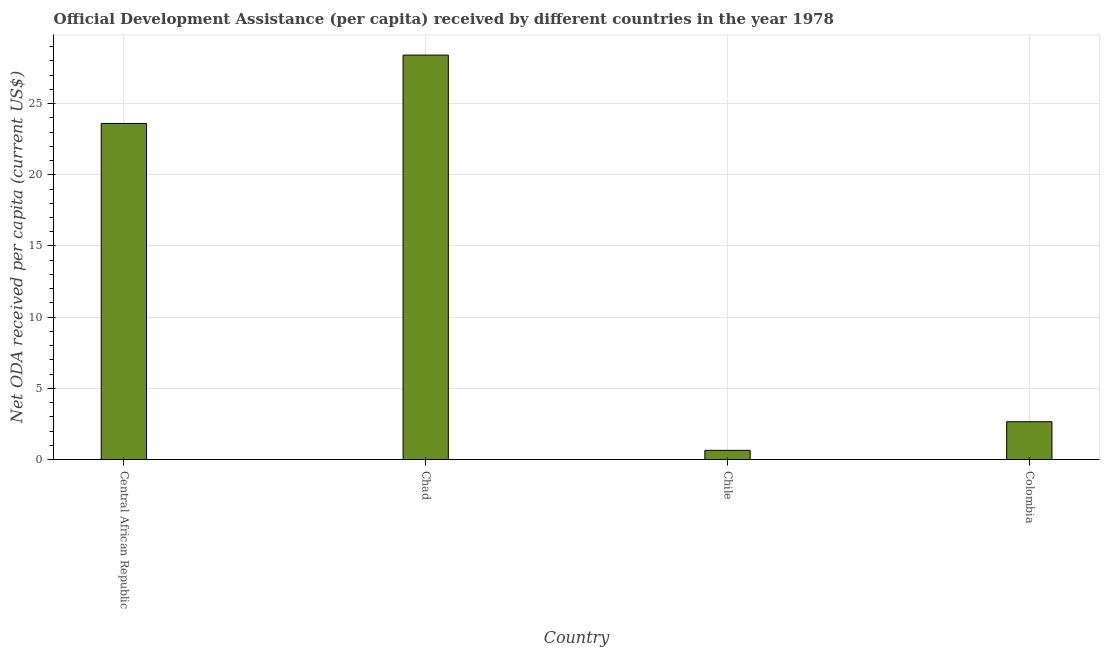What is the title of the graph?
Your response must be concise. Official Development Assistance (per capita) received by different countries in the year 1978. What is the label or title of the X-axis?
Ensure brevity in your answer.  Country. What is the label or title of the Y-axis?
Provide a short and direct response. Net ODA received per capita (current US$). What is the net oda received per capita in Chad?
Your answer should be compact. 28.4. Across all countries, what is the maximum net oda received per capita?
Provide a succinct answer. 28.4. Across all countries, what is the minimum net oda received per capita?
Ensure brevity in your answer.  0.66. In which country was the net oda received per capita maximum?
Offer a very short reply. Chad. What is the sum of the net oda received per capita?
Offer a very short reply. 55.32. What is the difference between the net oda received per capita in Chad and Colombia?
Your response must be concise. 25.73. What is the average net oda received per capita per country?
Offer a terse response. 13.83. What is the median net oda received per capita?
Provide a short and direct response. 13.13. What is the ratio of the net oda received per capita in Central African Republic to that in Chad?
Your response must be concise. 0.83. Is the difference between the net oda received per capita in Chad and Chile greater than the difference between any two countries?
Give a very brief answer. Yes. What is the difference between the highest and the second highest net oda received per capita?
Your answer should be compact. 4.8. Is the sum of the net oda received per capita in Chad and Colombia greater than the maximum net oda received per capita across all countries?
Offer a very short reply. Yes. What is the difference between the highest and the lowest net oda received per capita?
Provide a short and direct response. 27.74. In how many countries, is the net oda received per capita greater than the average net oda received per capita taken over all countries?
Provide a short and direct response. 2. What is the difference between two consecutive major ticks on the Y-axis?
Ensure brevity in your answer.  5. Are the values on the major ticks of Y-axis written in scientific E-notation?
Your answer should be compact. No. What is the Net ODA received per capita (current US$) in Central African Republic?
Keep it short and to the point. 23.6. What is the Net ODA received per capita (current US$) in Chad?
Make the answer very short. 28.4. What is the Net ODA received per capita (current US$) of Chile?
Offer a terse response. 0.66. What is the Net ODA received per capita (current US$) in Colombia?
Provide a succinct answer. 2.67. What is the difference between the Net ODA received per capita (current US$) in Central African Republic and Chad?
Your answer should be very brief. -4.8. What is the difference between the Net ODA received per capita (current US$) in Central African Republic and Chile?
Your answer should be compact. 22.94. What is the difference between the Net ODA received per capita (current US$) in Central African Republic and Colombia?
Your response must be concise. 20.93. What is the difference between the Net ODA received per capita (current US$) in Chad and Chile?
Offer a very short reply. 27.74. What is the difference between the Net ODA received per capita (current US$) in Chad and Colombia?
Keep it short and to the point. 25.73. What is the difference between the Net ODA received per capita (current US$) in Chile and Colombia?
Your response must be concise. -2.01. What is the ratio of the Net ODA received per capita (current US$) in Central African Republic to that in Chad?
Make the answer very short. 0.83. What is the ratio of the Net ODA received per capita (current US$) in Central African Republic to that in Chile?
Your response must be concise. 35.95. What is the ratio of the Net ODA received per capita (current US$) in Central African Republic to that in Colombia?
Ensure brevity in your answer.  8.85. What is the ratio of the Net ODA received per capita (current US$) in Chad to that in Chile?
Ensure brevity in your answer.  43.27. What is the ratio of the Net ODA received per capita (current US$) in Chad to that in Colombia?
Make the answer very short. 10.65. What is the ratio of the Net ODA received per capita (current US$) in Chile to that in Colombia?
Your response must be concise. 0.25. 